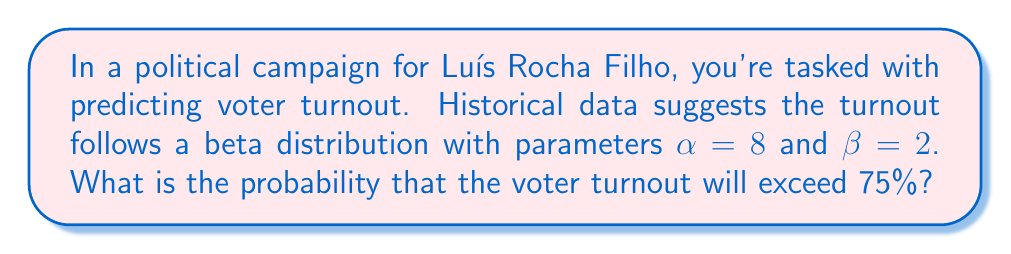Could you help me with this problem? To solve this problem, we'll use the properties of the beta distribution and the concept of the complementary cumulative distribution function (CCDF).

1) The beta distribution is defined on the interval [0, 1], making it suitable for modeling proportions like voter turnout.

2) Given: $\alpha = 8$, $\beta = 2$, and we want to find $P(X > 0.75)$ where X is the voter turnout.

3) The cumulative distribution function (CDF) of the beta distribution is given by the regularized incomplete beta function:

   $F(x; \alpha, \beta) = I_x(\alpha, \beta)$

4) We need to find the complementary CDF:

   $P(X > 0.75) = 1 - P(X \leq 0.75) = 1 - F(0.75; 8, 2)$

5) The regularized incomplete beta function doesn't have a simple closed form, so we typically use statistical software or numerical methods to compute it.

6) Using a statistical calculator or software, we can compute:

   $F(0.75; 8, 2) \approx 0.2061$

7) Therefore:

   $P(X > 0.75) = 1 - 0.2061 \approx 0.7939$

Thus, there is approximately a 79.39% chance that the voter turnout will exceed 75%.
Answer: $0.7939$ or $79.39\%$ 